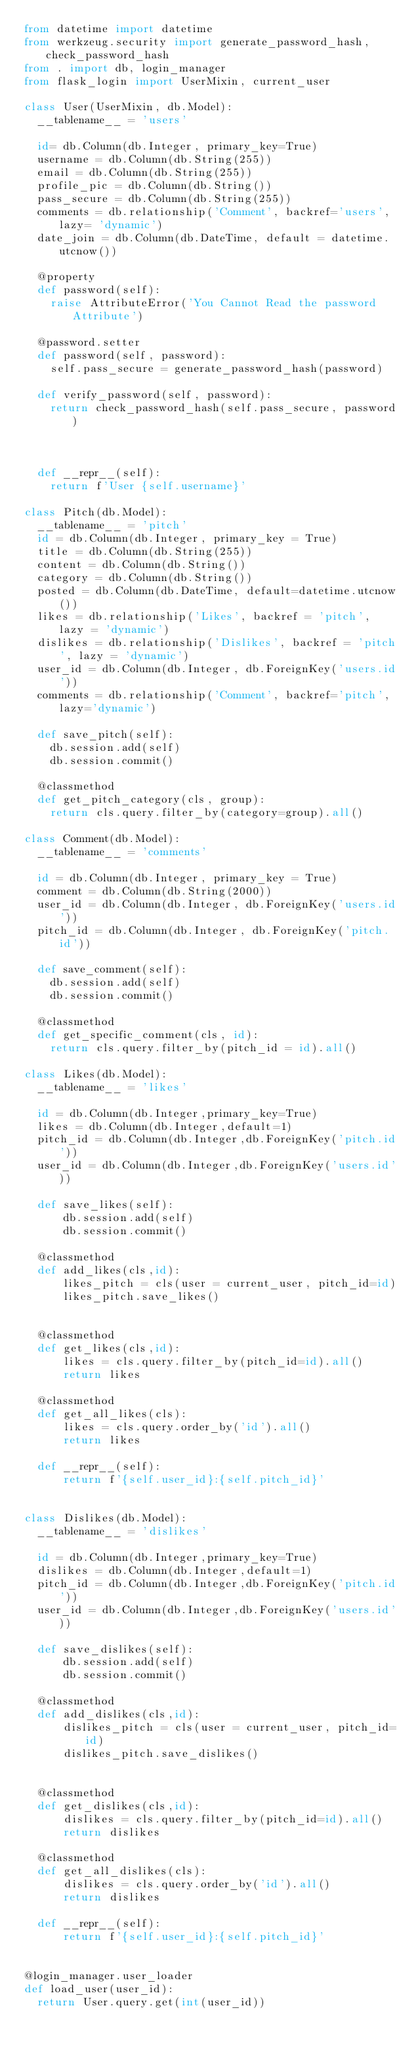<code> <loc_0><loc_0><loc_500><loc_500><_Python_>from datetime import datetime
from werkzeug.security import generate_password_hash, check_password_hash
from . import db, login_manager
from flask_login import UserMixin, current_user

class User(UserMixin, db.Model):
  __tablename__ = 'users'

  id= db.Column(db.Integer, primary_key=True)
  username = db.Column(db.String(255))
  email = db.Column(db.String(255))
  profile_pic = db.Column(db.String())
  pass_secure = db.Column(db.String(255))
  comments = db.relationship('Comment', backref='users', lazy= 'dynamic')
  date_join = db.Column(db.DateTime, default = datetime.utcnow())

  @property
  def password(self):
    raise AttributeError('You Cannot Read the password Attribute')

  @password.setter
  def password(self, password):
    self.pass_secure = generate_password_hash(password)

  def verify_password(self, password):
    return check_password_hash(self.pass_secure, password)



  def __repr__(self):
    return f'User {self.username}'

class Pitch(db.Model):
  __tablename__ = 'pitch'
  id = db.Column(db.Integer, primary_key = True)
  title = db.Column(db.String(255))
  content = db.Column(db.String())
  category = db.Column(db.String())
  posted = db.Column(db.DateTime, default=datetime.utcnow())
  likes = db.relationship('Likes', backref = 'pitch', lazy = 'dynamic')
  dislikes = db.relationship('Dislikes', backref = 'pitch', lazy = 'dynamic')
  user_id = db.Column(db.Integer, db.ForeignKey('users.id'))
  comments = db.relationship('Comment', backref='pitch', lazy='dynamic')

  def save_pitch(self):
    db.session.add(self)
    db.session.commit()

  @classmethod
  def get_pitch_category(cls, group):
    return cls.query.filter_by(category=group).all()
    
class Comment(db.Model):
  __tablename__ = 'comments'

  id = db.Column(db.Integer, primary_key = True)
  comment = db.Column(db.String(2000))
  user_id = db.Column(db.Integer, db.ForeignKey('users.id'))
  pitch_id = db.Column(db.Integer, db.ForeignKey('pitch.id'))

  def save_comment(self):
    db.session.add(self)
    db.session.commit()
  
  @classmethod
  def get_specific_comment(cls, id):
    return cls.query.filter_by(pitch_id = id).all()

class Likes(db.Model):
  __tablename__ = 'likes'

  id = db.Column(db.Integer,primary_key=True)
  likes = db.Column(db.Integer,default=1)
  pitch_id = db.Column(db.Integer,db.ForeignKey('pitch.id'))
  user_id = db.Column(db.Integer,db.ForeignKey('users.id'))

  def save_likes(self):
      db.session.add(self)
      db.session.commit()

  @classmethod
  def add_likes(cls,id):
      likes_pitch = cls(user = current_user, pitch_id=id)
      likes_pitch.save_likes()

  
  @classmethod
  def get_likes(cls,id):
      likes = cls.query.filter_by(pitch_id=id).all()
      return likes

  @classmethod
  def get_all_likes(cls):
      likes = cls.query.order_by('id').all()
      return likes

  def __repr__(self):
      return f'{self.user_id}:{self.pitch_id}'


class Dislikes(db.Model):
  __tablename__ = 'dislikes'

  id = db.Column(db.Integer,primary_key=True)
  dislikes = db.Column(db.Integer,default=1)
  pitch_id = db.Column(db.Integer,db.ForeignKey('pitch.id'))
  user_id = db.Column(db.Integer,db.ForeignKey('users.id'))

  def save_dislikes(self):
      db.session.add(self)
      db.session.commit()

  @classmethod
  def add_dislikes(cls,id):
      dislikes_pitch = cls(user = current_user, pitch_id=id)
      dislikes_pitch.save_dislikes()

  
  @classmethod
  def get_dislikes(cls,id):
      dislikes = cls.query.filter_by(pitch_id=id).all()
      return dislikes

  @classmethod
  def get_all_dislikes(cls):
      dislikes = cls.query.order_by('id').all()
      return dislikes

  def __repr__(self):
      return f'{self.user_id}:{self.pitch_id}'

      
@login_manager.user_loader
def load_user(user_id):
  return User.query.get(int(user_id))
</code> 